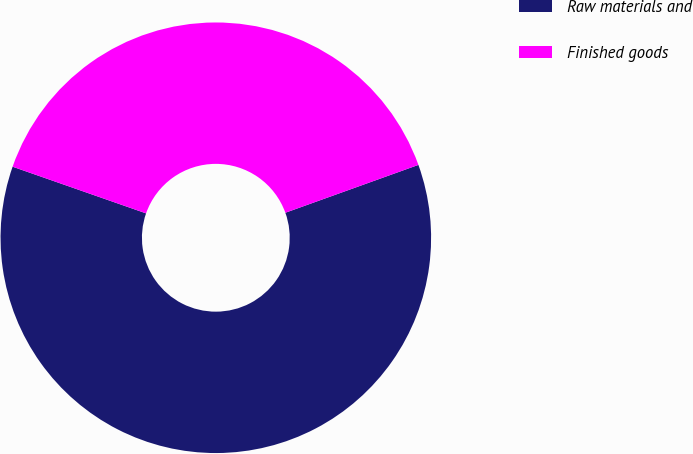Convert chart to OTSL. <chart><loc_0><loc_0><loc_500><loc_500><pie_chart><fcel>Raw materials and<fcel>Finished goods<nl><fcel>60.85%<fcel>39.15%<nl></chart> 